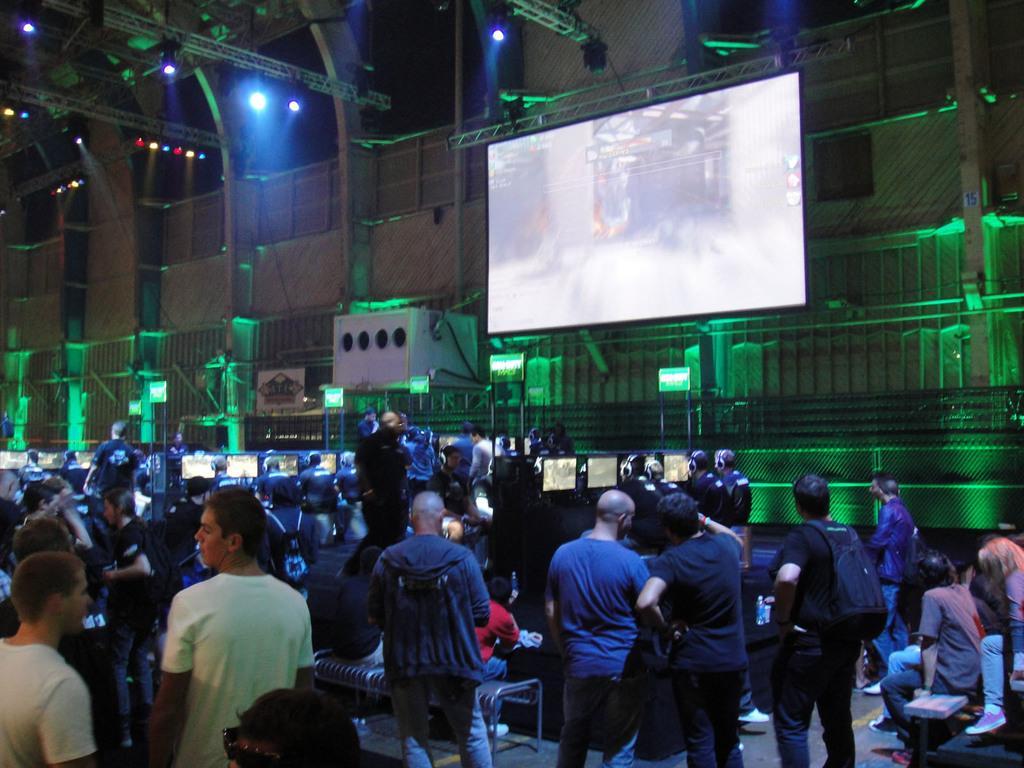Could you give a brief overview of what you see in this image? In this image there are so many people standing and few are sitting on the benches, in front of them there is a big screen, beside that there is an object, screens, railing, some metal structures and focus lights. 